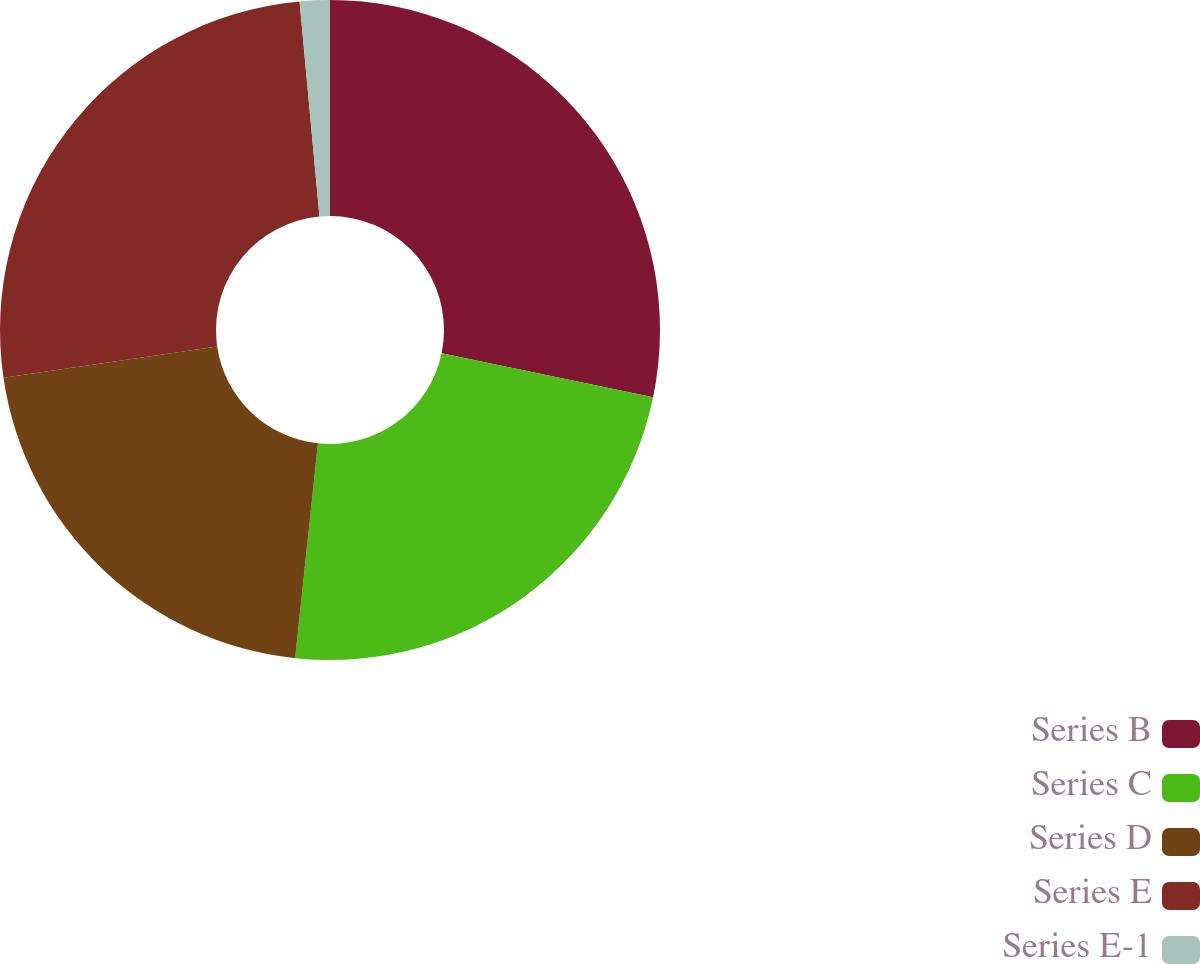Convert chart to OTSL. <chart><loc_0><loc_0><loc_500><loc_500><pie_chart><fcel>Series B<fcel>Series C<fcel>Series D<fcel>Series E<fcel>Series E-1<nl><fcel>28.26%<fcel>23.42%<fcel>21.0%<fcel>25.84%<fcel>1.47%<nl></chart> 